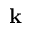Convert formula to latex. <formula><loc_0><loc_0><loc_500><loc_500>k</formula> 